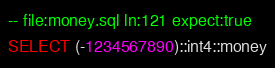<code> <loc_0><loc_0><loc_500><loc_500><_SQL_>-- file:money.sql ln:121 expect:true
SELECT (-1234567890)::int4::money
</code> 